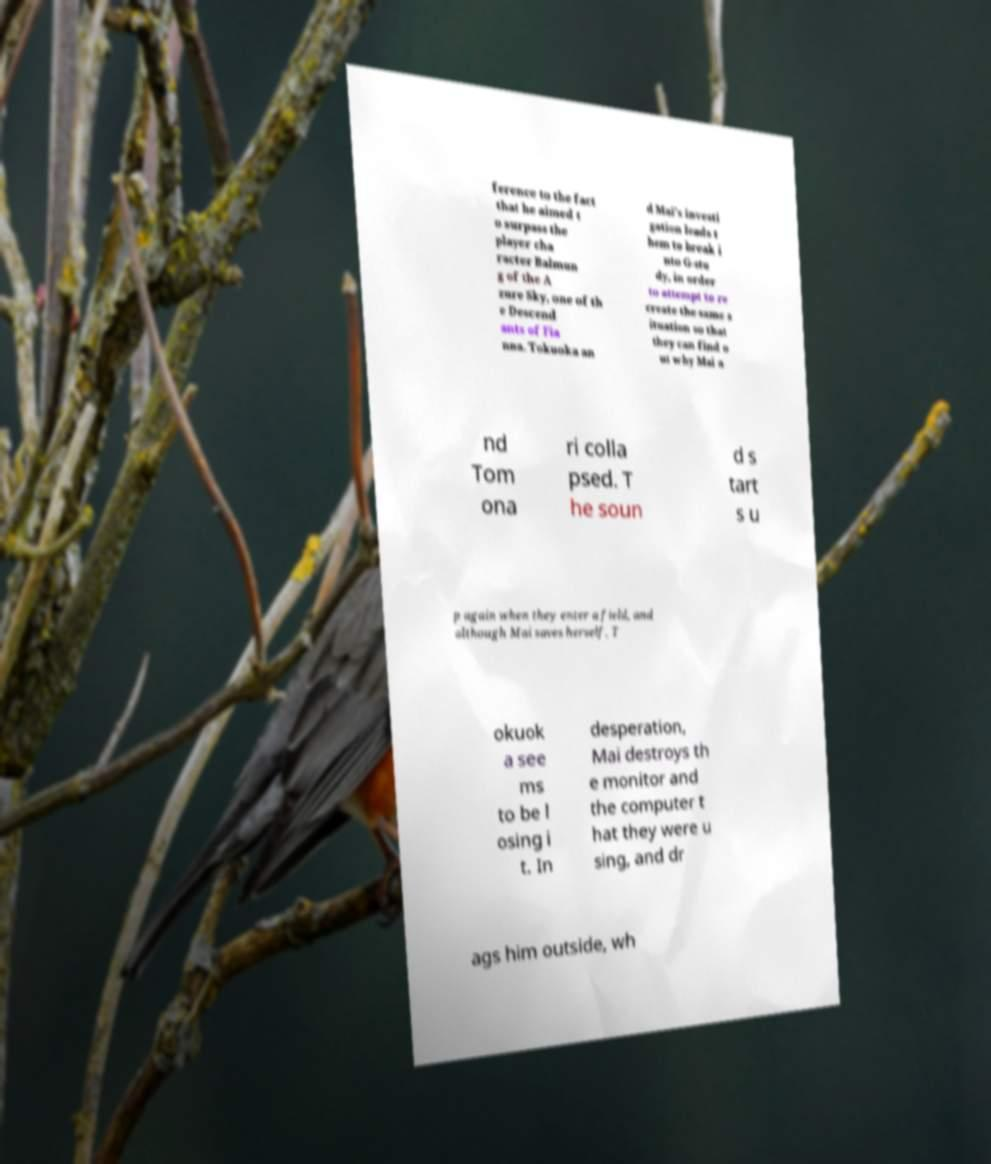Please identify and transcribe the text found in this image. ference to the fact that he aimed t o surpass the player cha racter Balmun g of the A zure Sky, one of th e Descend ants of Fia nna. Tokuoka an d Mai's investi gation leads t hem to break i nto G-stu dy, in order to attempt to re create the same s ituation so that they can find o ut why Mai a nd Tom ona ri colla psed. T he soun d s tart s u p again when they enter a field, and although Mai saves herself, T okuok a see ms to be l osing i t. In desperation, Mai destroys th e monitor and the computer t hat they were u sing, and dr ags him outside, wh 